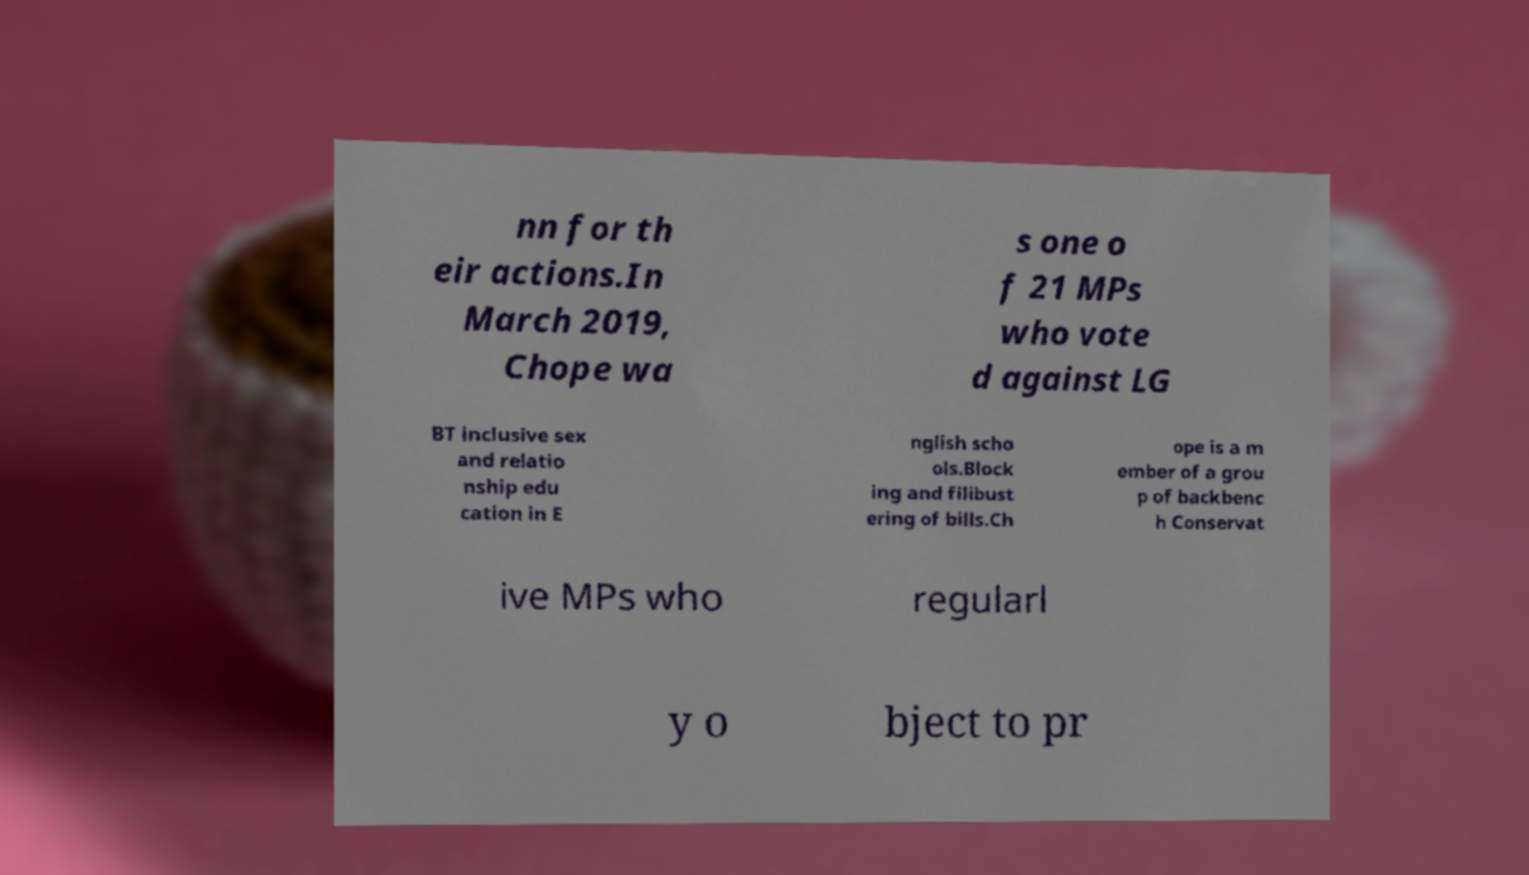Please read and relay the text visible in this image. What does it say? nn for th eir actions.In March 2019, Chope wa s one o f 21 MPs who vote d against LG BT inclusive sex and relatio nship edu cation in E nglish scho ols.Block ing and filibust ering of bills.Ch ope is a m ember of a grou p of backbenc h Conservat ive MPs who regularl y o bject to pr 